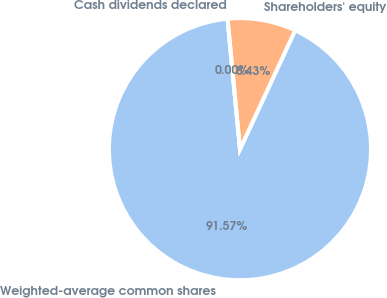<chart> <loc_0><loc_0><loc_500><loc_500><pie_chart><fcel>Weighted-average common shares<fcel>Shareholders' equity<fcel>Cash dividends declared<nl><fcel>91.57%<fcel>8.43%<fcel>0.0%<nl></chart> 